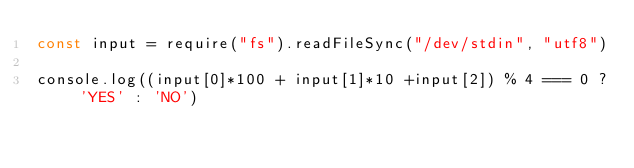<code> <loc_0><loc_0><loc_500><loc_500><_JavaScript_>const input = require("fs").readFileSync("/dev/stdin", "utf8")

console.log((input[0]*100 + input[1]*10 +input[2]) % 4 === 0 ? 'YES' : 'NO')</code> 